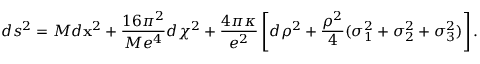Convert formula to latex. <formula><loc_0><loc_0><loc_500><loc_500>d s ^ { 2 } = M d { x } ^ { 2 } + { \frac { 1 6 \pi ^ { 2 } } { M e ^ { 4 } } } d \chi ^ { 2 } + \frac { 4 \pi \kappa } { e ^ { 2 } } \left [ d \rho ^ { 2 } + { \frac { \rho ^ { 2 } } { 4 } } ( \sigma _ { 1 } ^ { 2 } + \sigma _ { 2 } ^ { 2 } + \sigma _ { 3 } ^ { 2 } ) \right ] .</formula> 